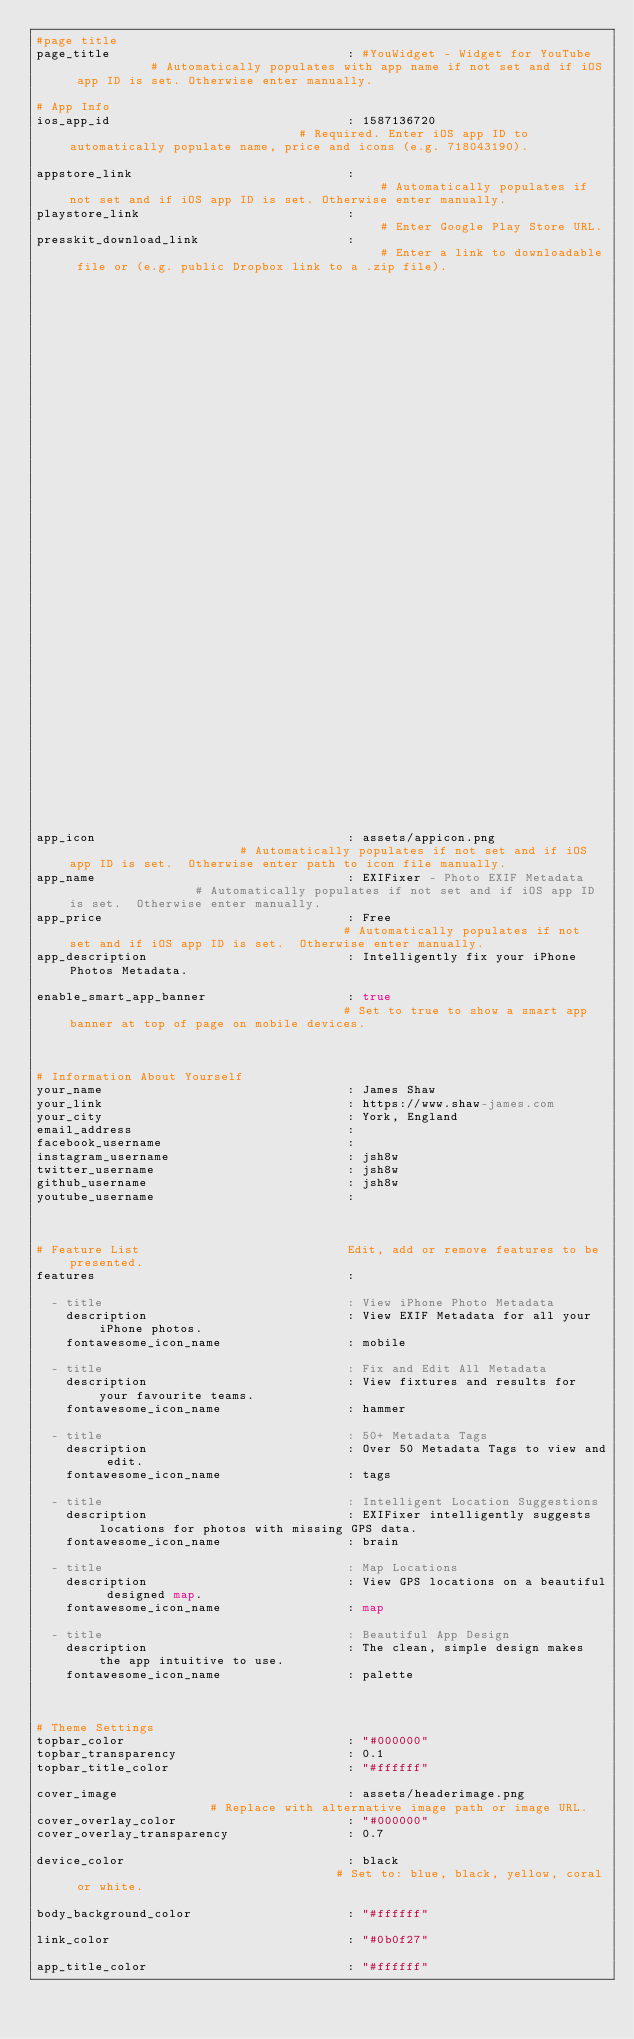<code> <loc_0><loc_0><loc_500><loc_500><_YAML_>#page title
page_title                                : #YouWidget - Widget for YouTube            # Automatically populates with app name if not set and if iOS app ID is set. Otherwise enter manually.

# App Info
ios_app_id                                : 1587136720                                # Required. Enter iOS app ID to automatically populate name, price and icons (e.g. 718043190).

appstore_link                             :                                           # Automatically populates if not set and if iOS app ID is set. Otherwise enter manually.
playstore_link                            :                                           # Enter Google Play Store URL.
presskit_download_link                    :                                           # Enter a link to downloadable file or (e.g. public Dropbox link to a .zip file).
                                                                                      # Or upload your press kit file to assets and set path accordingly (e.g. "assets/your_press_kit.zip").

app_icon                                  : assets/appicon.png                        # Automatically populates if not set and if iOS app ID is set.  Otherwise enter path to icon file manually.
app_name                                  : EXIFixer - Photo EXIF Metadata                  # Automatically populates if not set and if iOS app ID is set.  Otherwise enter manually.
app_price                                 : Free                                      # Automatically populates if not set and if iOS app ID is set.  Otherwise enter manually.
app_description                           : Intelligently fix your iPhone Photos Metadata.

enable_smart_app_banner                   : true                                      # Set to true to show a smart app banner at top of page on mobile devices.



# Information About Yourself
your_name                                 : James Shaw
your_link                                 : https://www.shaw-james.com
your_city                                 : York, England
email_address                             :
facebook_username                         :
instagram_username                        : jsh8w
twitter_username                          : jsh8w
github_username                           : jsh8w
youtube_username                          :



# Feature List                            Edit, add or remove features to be presented.
features                                  :

  - title                                 : View iPhone Photo Metadata
    description                           : View EXIF Metadata for all your iPhone photos.
    fontawesome_icon_name                 : mobile

  - title                                 : Fix and Edit All Metadata
    description                           : View fixtures and results for your favourite teams.
    fontawesome_icon_name                 : hammer

  - title                                 : 50+ Metadata Tags
    description                           : Over 50 Metadata Tags to view and edit.
    fontawesome_icon_name                 : tags

  - title                                 : Intelligent Location Suggestions
    description                           : EXIFixer intelligently suggests locations for photos with missing GPS data.
    fontawesome_icon_name                 : brain

  - title                                 : Map Locations
    description                           : View GPS locations on a beautiful designed map.
    fontawesome_icon_name                 : map

  - title                                 : Beautiful App Design
    description                           : The clean, simple design makes the app intuitive to use.
    fontawesome_icon_name                 : palette



# Theme Settings
topbar_color                              : "#000000"
topbar_transparency                       : 0.1
topbar_title_color                        : "#ffffff"

cover_image                               : assets/headerimage.png                    # Replace with alternative image path or image URL.
cover_overlay_color                       : "#000000"
cover_overlay_transparency                : 0.7

device_color                              : black                                     # Set to: blue, black, yellow, coral or white.

body_background_color                     : "#ffffff"

link_color                                : "#0b0f27"

app_title_color                           : "#ffffff"</code> 